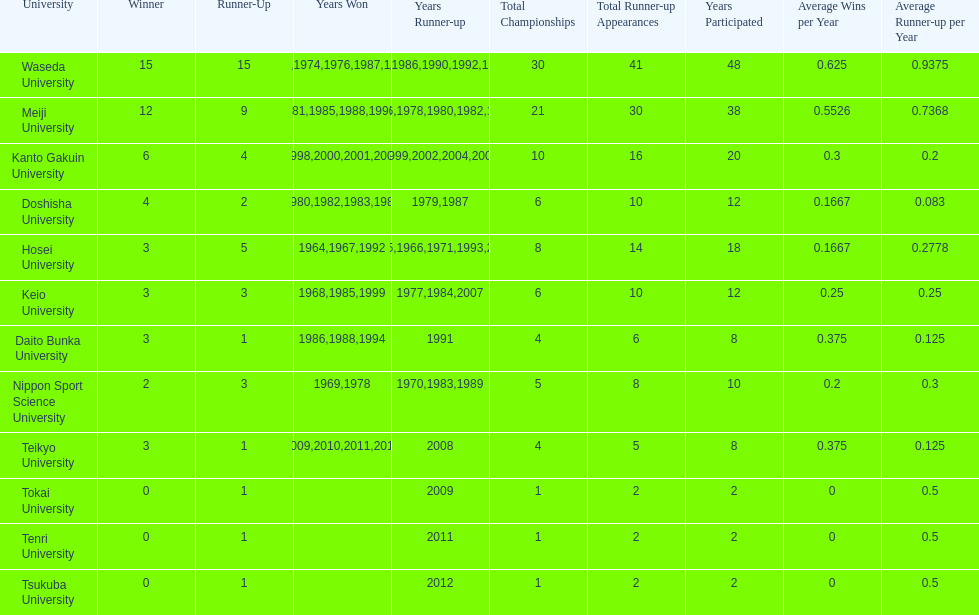Hosei won in 1964. who won the next year? Waseda University. 